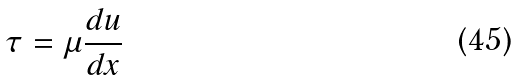Convert formula to latex. <formula><loc_0><loc_0><loc_500><loc_500>\tau = \mu \frac { d u } { d x }</formula> 